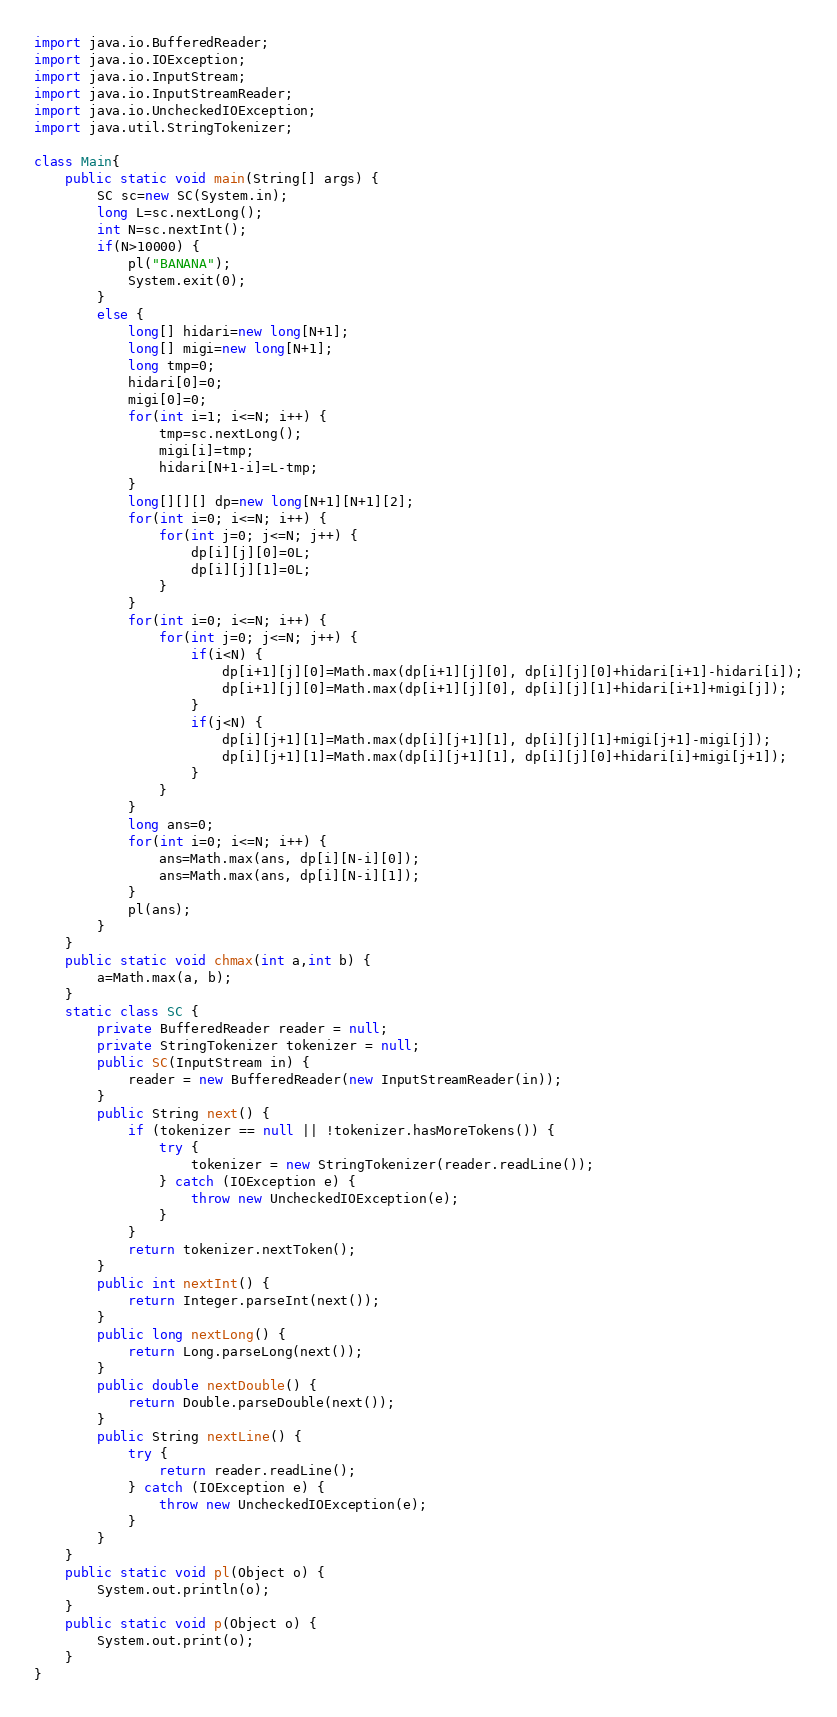Convert code to text. <code><loc_0><loc_0><loc_500><loc_500><_Java_>import java.io.BufferedReader;
import java.io.IOException;
import java.io.InputStream;
import java.io.InputStreamReader;
import java.io.UncheckedIOException;
import java.util.StringTokenizer;

class Main{
	public static void main(String[] args) {
		SC sc=new SC(System.in);
		long L=sc.nextLong();
		int N=sc.nextInt();
		if(N>10000) {
			pl("BANANA");
			System.exit(0);
		}
		else {
			long[] hidari=new long[N+1];
			long[] migi=new long[N+1];
			long tmp=0;
			hidari[0]=0;
			migi[0]=0;
			for(int i=1; i<=N; i++) {
				tmp=sc.nextLong();
				migi[i]=tmp;
				hidari[N+1-i]=L-tmp;
			}
			long[][][] dp=new long[N+1][N+1][2];
			for(int i=0; i<=N; i++) {
				for(int j=0; j<=N; j++) {
					dp[i][j][0]=0L;
					dp[i][j][1]=0L;
				}
			}
			for(int i=0; i<=N; i++) {
				for(int j=0; j<=N; j++) {
					if(i<N) {
						dp[i+1][j][0]=Math.max(dp[i+1][j][0], dp[i][j][0]+hidari[i+1]-hidari[i]);
						dp[i+1][j][0]=Math.max(dp[i+1][j][0], dp[i][j][1]+hidari[i+1]+migi[j]);
					}
					if(j<N) {
						dp[i][j+1][1]=Math.max(dp[i][j+1][1], dp[i][j][1]+migi[j+1]-migi[j]);
						dp[i][j+1][1]=Math.max(dp[i][j+1][1], dp[i][j][0]+hidari[i]+migi[j+1]);
					}
				}
			}
			long ans=0;
			for(int i=0; i<=N; i++) {
				ans=Math.max(ans, dp[i][N-i][0]);
				ans=Math.max(ans, dp[i][N-i][1]);
			}
			pl(ans);
		}
	}
	public static void chmax(int a,int b) {
		a=Math.max(a, b);
	}
	static class SC {
		private BufferedReader reader = null;
		private StringTokenizer tokenizer = null;
		public SC(InputStream in) {
			reader = new BufferedReader(new InputStreamReader(in));
		}
		public String next() {
			if (tokenizer == null || !tokenizer.hasMoreTokens()) {
				try {
					tokenizer = new StringTokenizer(reader.readLine());
				} catch (IOException e) {
					throw new UncheckedIOException(e);
				}
			}
			return tokenizer.nextToken();
		}
		public int nextInt() {
			return Integer.parseInt(next());
		}
		public long nextLong() {
			return Long.parseLong(next());
		}
		public double nextDouble() {
			return Double.parseDouble(next());
		}
		public String nextLine() {
			try {
				return reader.readLine();
			} catch (IOException e) {
				throw new UncheckedIOException(e);
			}
		}
	}
	public static void pl(Object o) {
		System.out.println(o);
	}
	public static void p(Object o) {
		System.out.print(o);
	}
}
</code> 